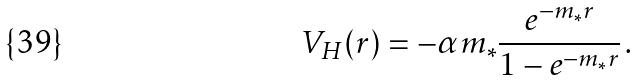Convert formula to latex. <formula><loc_0><loc_0><loc_500><loc_500>V _ { H } ( { r } ) = - \alpha m _ { * } \frac { e ^ { - m _ { * } r } } { 1 - e ^ { - m _ { * } r } } \, .</formula> 